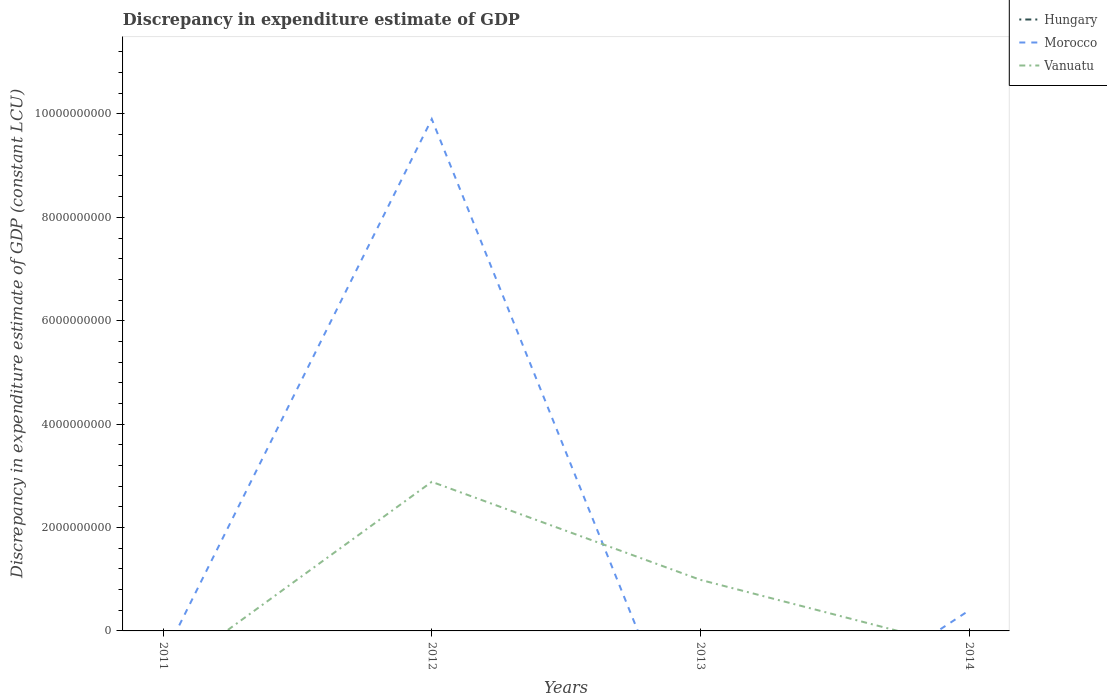What is the total discrepancy in expenditure estimate of GDP in Morocco in the graph?
Your answer should be very brief. 9.51e+09. What is the difference between the highest and the second highest discrepancy in expenditure estimate of GDP in Morocco?
Provide a short and direct response. 9.90e+09. What is the difference between the highest and the lowest discrepancy in expenditure estimate of GDP in Vanuatu?
Ensure brevity in your answer.  2. How many lines are there?
Make the answer very short. 2. How many years are there in the graph?
Your response must be concise. 4. Are the values on the major ticks of Y-axis written in scientific E-notation?
Provide a succinct answer. No. Does the graph contain any zero values?
Your response must be concise. Yes. Does the graph contain grids?
Keep it short and to the point. No. Where does the legend appear in the graph?
Your answer should be compact. Top right. How many legend labels are there?
Offer a terse response. 3. What is the title of the graph?
Your response must be concise. Discrepancy in expenditure estimate of GDP. Does "Fragile and conflict affected situations" appear as one of the legend labels in the graph?
Keep it short and to the point. No. What is the label or title of the X-axis?
Your answer should be compact. Years. What is the label or title of the Y-axis?
Offer a terse response. Discrepancy in expenditure estimate of GDP (constant LCU). What is the Discrepancy in expenditure estimate of GDP (constant LCU) in Vanuatu in 2011?
Your answer should be compact. 0. What is the Discrepancy in expenditure estimate of GDP (constant LCU) of Hungary in 2012?
Provide a short and direct response. 0. What is the Discrepancy in expenditure estimate of GDP (constant LCU) in Morocco in 2012?
Provide a succinct answer. 9.90e+09. What is the Discrepancy in expenditure estimate of GDP (constant LCU) in Vanuatu in 2012?
Your answer should be compact. 2.88e+09. What is the Discrepancy in expenditure estimate of GDP (constant LCU) of Vanuatu in 2013?
Give a very brief answer. 9.88e+08. What is the Discrepancy in expenditure estimate of GDP (constant LCU) in Hungary in 2014?
Make the answer very short. 0. What is the Discrepancy in expenditure estimate of GDP (constant LCU) of Morocco in 2014?
Provide a short and direct response. 3.95e+08. Across all years, what is the maximum Discrepancy in expenditure estimate of GDP (constant LCU) in Morocco?
Your response must be concise. 9.90e+09. Across all years, what is the maximum Discrepancy in expenditure estimate of GDP (constant LCU) of Vanuatu?
Provide a succinct answer. 2.88e+09. Across all years, what is the minimum Discrepancy in expenditure estimate of GDP (constant LCU) of Morocco?
Make the answer very short. 0. Across all years, what is the minimum Discrepancy in expenditure estimate of GDP (constant LCU) in Vanuatu?
Provide a short and direct response. 0. What is the total Discrepancy in expenditure estimate of GDP (constant LCU) in Hungary in the graph?
Ensure brevity in your answer.  0. What is the total Discrepancy in expenditure estimate of GDP (constant LCU) in Morocco in the graph?
Your response must be concise. 1.03e+1. What is the total Discrepancy in expenditure estimate of GDP (constant LCU) of Vanuatu in the graph?
Your answer should be compact. 3.87e+09. What is the difference between the Discrepancy in expenditure estimate of GDP (constant LCU) in Vanuatu in 2012 and that in 2013?
Offer a very short reply. 1.90e+09. What is the difference between the Discrepancy in expenditure estimate of GDP (constant LCU) in Morocco in 2012 and that in 2014?
Make the answer very short. 9.51e+09. What is the difference between the Discrepancy in expenditure estimate of GDP (constant LCU) in Morocco in 2012 and the Discrepancy in expenditure estimate of GDP (constant LCU) in Vanuatu in 2013?
Your answer should be compact. 8.91e+09. What is the average Discrepancy in expenditure estimate of GDP (constant LCU) in Morocco per year?
Your answer should be very brief. 2.57e+09. What is the average Discrepancy in expenditure estimate of GDP (constant LCU) in Vanuatu per year?
Give a very brief answer. 9.68e+08. In the year 2012, what is the difference between the Discrepancy in expenditure estimate of GDP (constant LCU) of Morocco and Discrepancy in expenditure estimate of GDP (constant LCU) of Vanuatu?
Offer a very short reply. 7.02e+09. What is the ratio of the Discrepancy in expenditure estimate of GDP (constant LCU) in Vanuatu in 2012 to that in 2013?
Your response must be concise. 2.92. What is the ratio of the Discrepancy in expenditure estimate of GDP (constant LCU) in Morocco in 2012 to that in 2014?
Your answer should be compact. 25.07. What is the difference between the highest and the lowest Discrepancy in expenditure estimate of GDP (constant LCU) in Morocco?
Provide a short and direct response. 9.90e+09. What is the difference between the highest and the lowest Discrepancy in expenditure estimate of GDP (constant LCU) of Vanuatu?
Keep it short and to the point. 2.88e+09. 